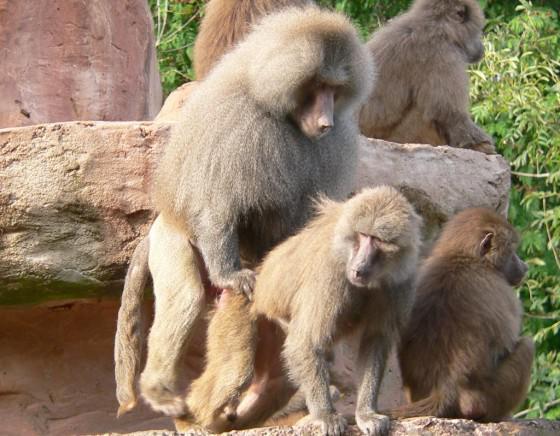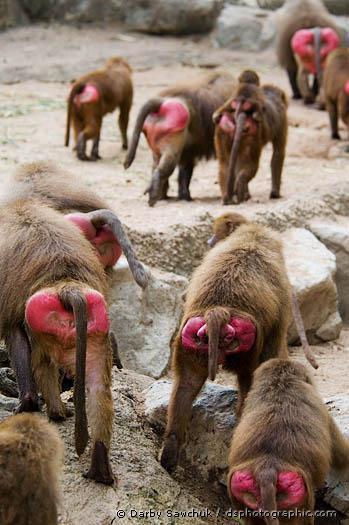The first image is the image on the left, the second image is the image on the right. Assess this claim about the two images: "At least one baboon is on the back of an animal bigger than itself, and no image contains more than two baboons.". Correct or not? Answer yes or no. No. The first image is the image on the left, the second image is the image on the right. Assess this claim about the two images: "There are more primates in the image on the right.". Correct or not? Answer yes or no. Yes. 